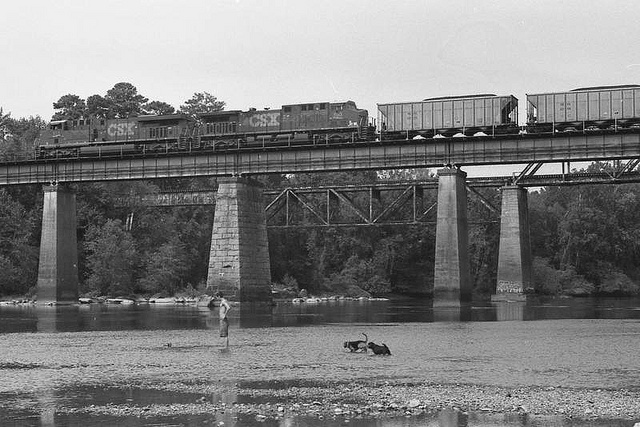Describe the objects in this image and their specific colors. I can see train in white, gray, black, darkgray, and lightgray tones, people in white, gray, darkgray, black, and lightgray tones, dog in gray, black, and white tones, and dog in black, gray, darkgray, and white tones in this image. 